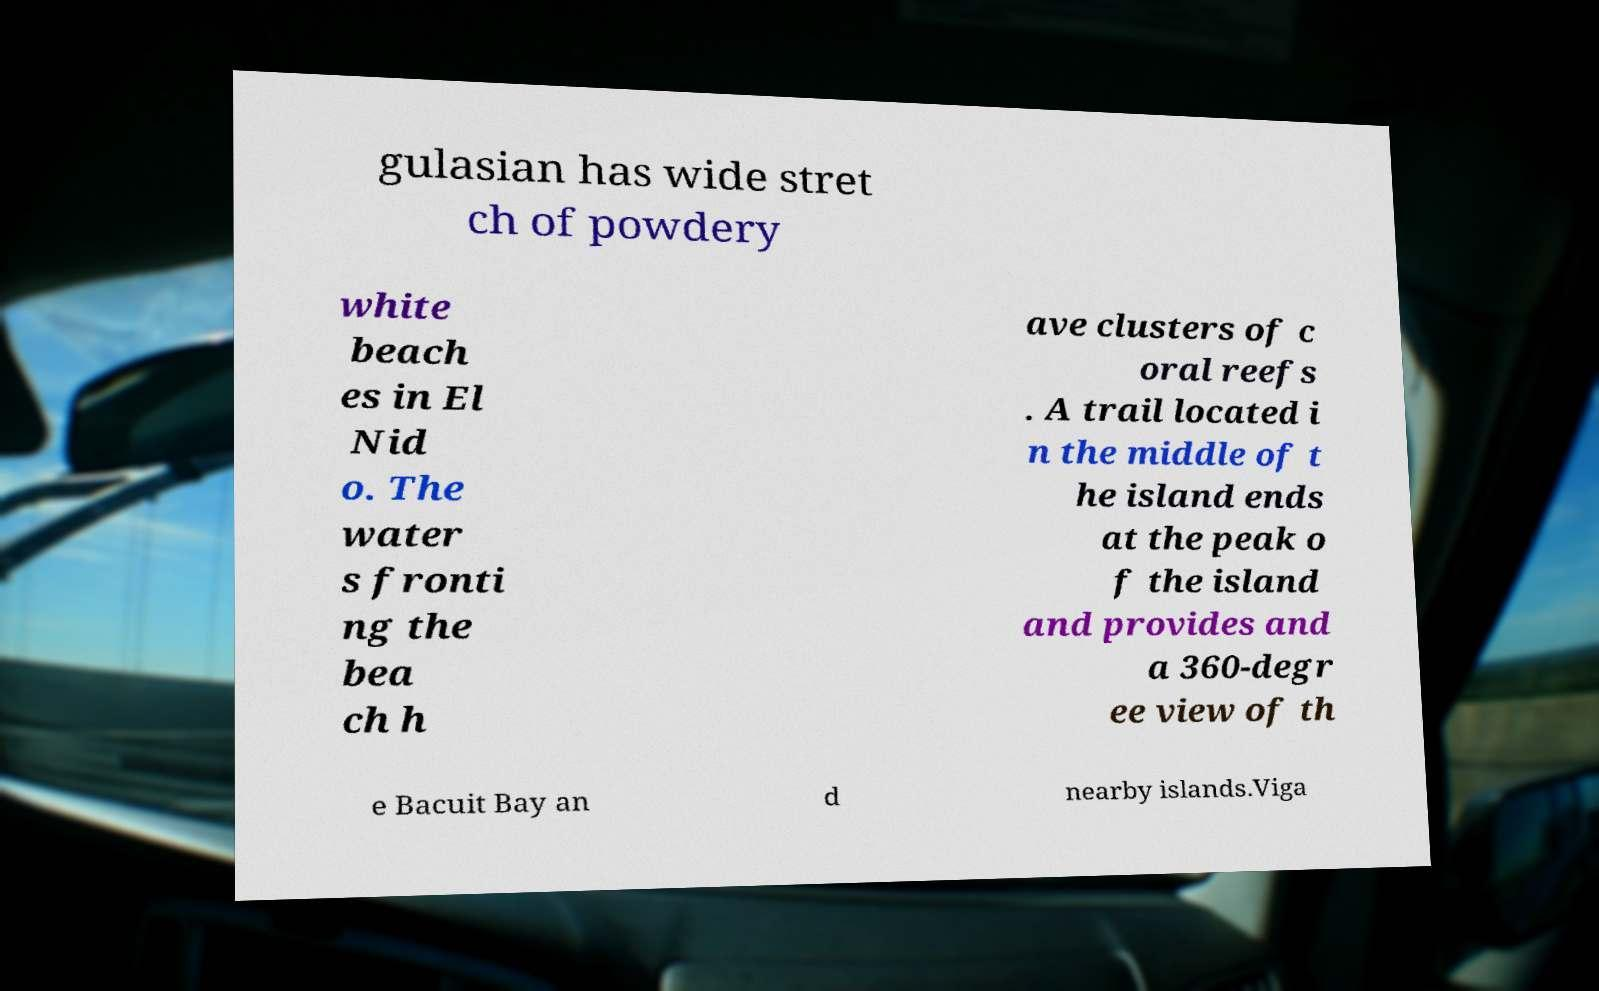Could you extract and type out the text from this image? gulasian has wide stret ch of powdery white beach es in El Nid o. The water s fronti ng the bea ch h ave clusters of c oral reefs . A trail located i n the middle of t he island ends at the peak o f the island and provides and a 360-degr ee view of th e Bacuit Bay an d nearby islands.Viga 